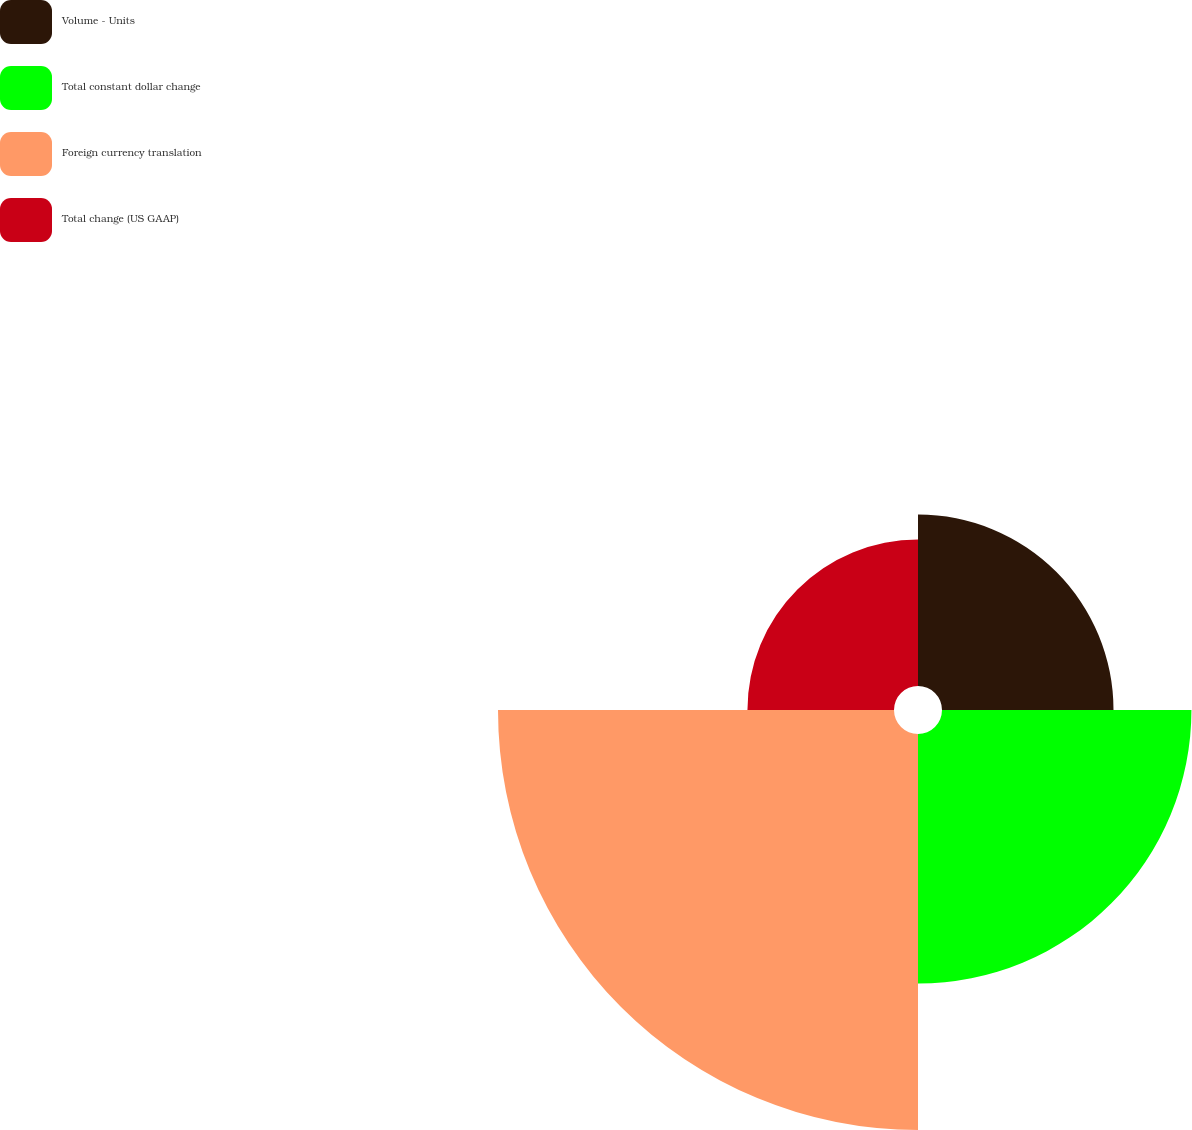<chart> <loc_0><loc_0><loc_500><loc_500><pie_chart><fcel>Volume - Units<fcel>Total constant dollar change<fcel>Foreign currency translation<fcel>Total change (US GAAP)<nl><fcel>17.8%<fcel>25.89%<fcel>41.1%<fcel>15.21%<nl></chart> 